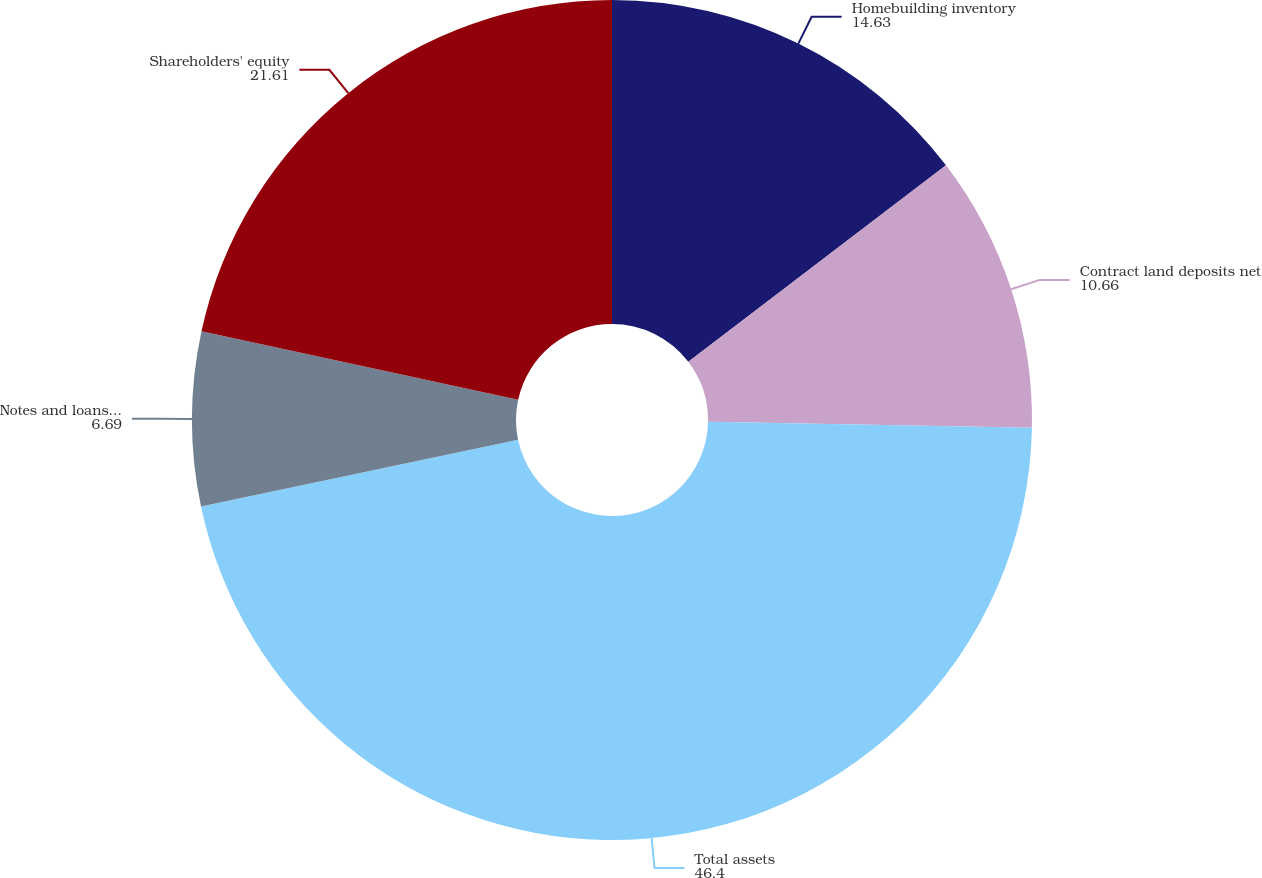Convert chart. <chart><loc_0><loc_0><loc_500><loc_500><pie_chart><fcel>Homebuilding inventory<fcel>Contract land deposits net<fcel>Total assets<fcel>Notes and loans payable<fcel>Shareholders' equity<nl><fcel>14.63%<fcel>10.66%<fcel>46.4%<fcel>6.69%<fcel>21.61%<nl></chart> 